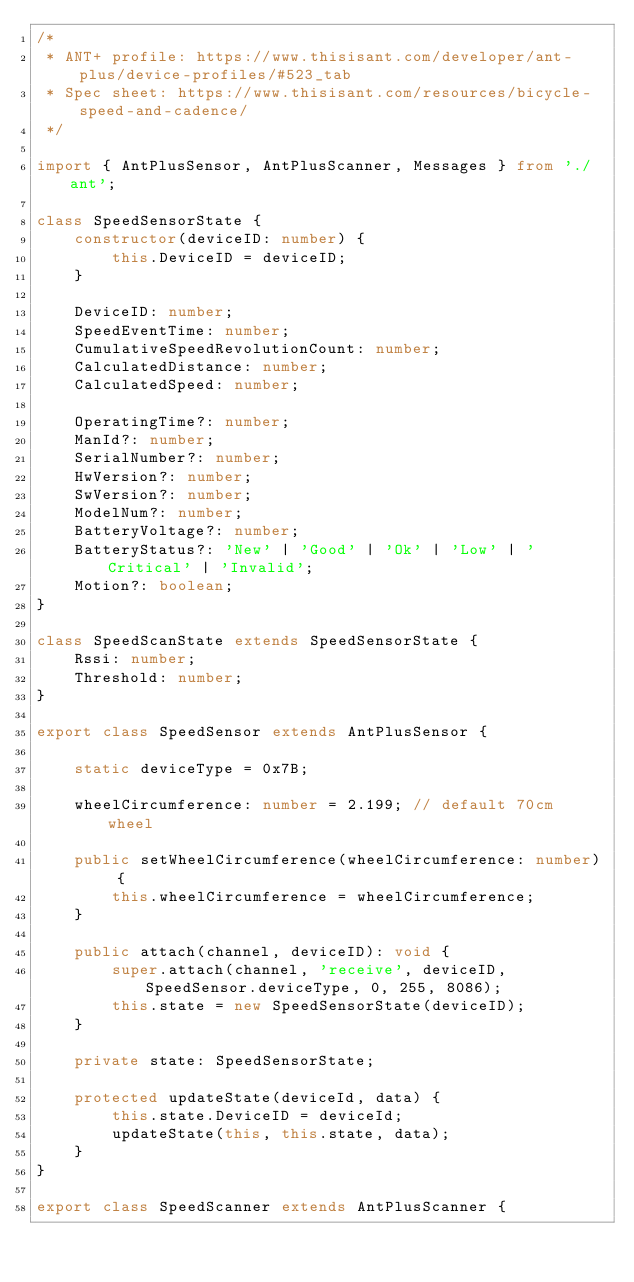Convert code to text. <code><loc_0><loc_0><loc_500><loc_500><_TypeScript_>/*
 * ANT+ profile: https://www.thisisant.com/developer/ant-plus/device-profiles/#523_tab
 * Spec sheet: https://www.thisisant.com/resources/bicycle-speed-and-cadence/
 */

import { AntPlusSensor, AntPlusScanner, Messages } from './ant';

class SpeedSensorState {
	constructor(deviceID: number) {
		this.DeviceID = deviceID;
	}

	DeviceID: number;
	SpeedEventTime: number;
	CumulativeSpeedRevolutionCount: number;
	CalculatedDistance: number;
	CalculatedSpeed: number;

	OperatingTime?: number;
	ManId?: number;
	SerialNumber?: number;
	HwVersion?: number;
	SwVersion?: number;
	ModelNum?: number;
	BatteryVoltage?: number;
	BatteryStatus?: 'New' | 'Good' | 'Ok' | 'Low' | 'Critical' | 'Invalid';
	Motion?: boolean;
}

class SpeedScanState extends SpeedSensorState {
	Rssi: number;
	Threshold: number;
}

export class SpeedSensor extends AntPlusSensor {

	static deviceType = 0x7B;

	wheelCircumference: number = 2.199; // default 70cm wheel

	public setWheelCircumference(wheelCircumference: number) {
		this.wheelCircumference = wheelCircumference;
	}

	public attach(channel, deviceID): void {
		super.attach(channel, 'receive', deviceID, SpeedSensor.deviceType, 0, 255, 8086);
		this.state = new SpeedSensorState(deviceID);
	}

	private state: SpeedSensorState;

	protected updateState(deviceId, data) {
		this.state.DeviceID = deviceId;
		updateState(this, this.state, data);
	}
}

export class SpeedScanner extends AntPlusScanner {</code> 